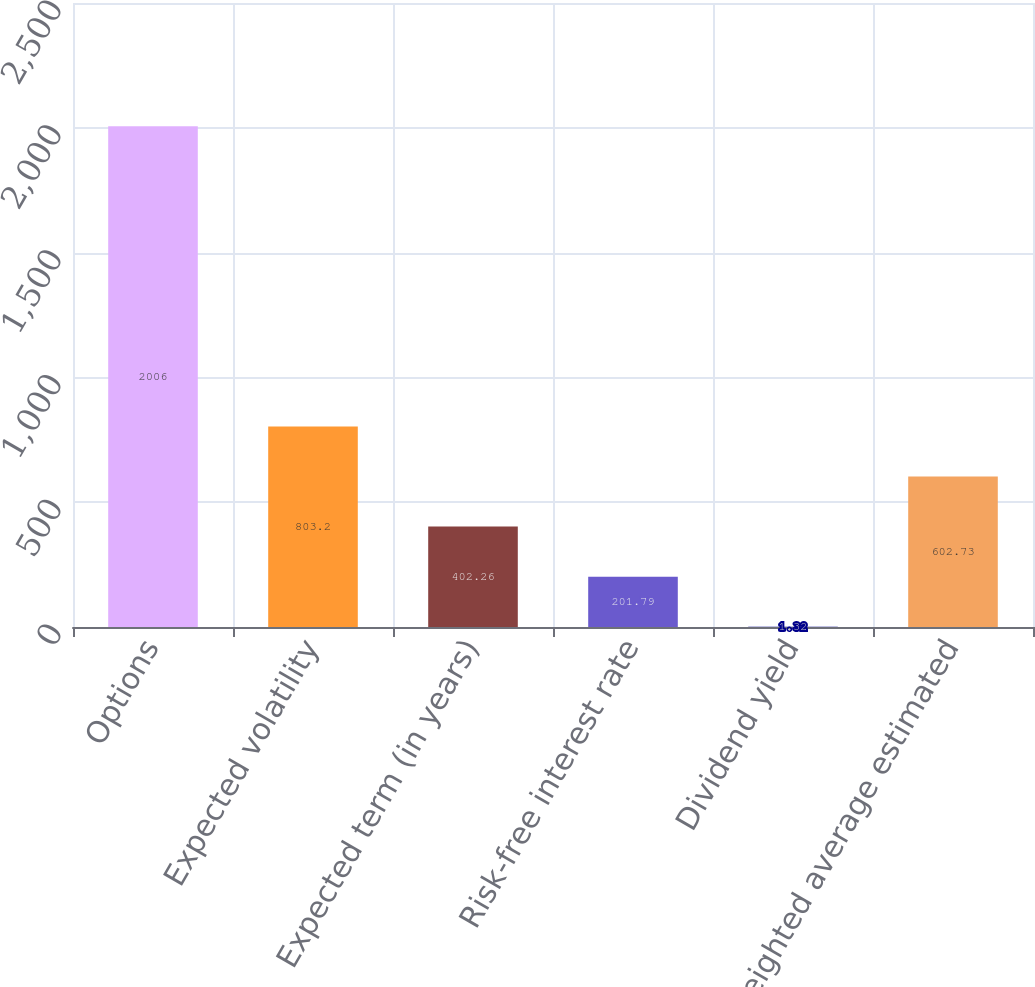Convert chart. <chart><loc_0><loc_0><loc_500><loc_500><bar_chart><fcel>Options<fcel>Expected volatility<fcel>Expected term (in years)<fcel>Risk-free interest rate<fcel>Dividend yield<fcel>Weighted average estimated<nl><fcel>2006<fcel>803.2<fcel>402.26<fcel>201.79<fcel>1.32<fcel>602.73<nl></chart> 